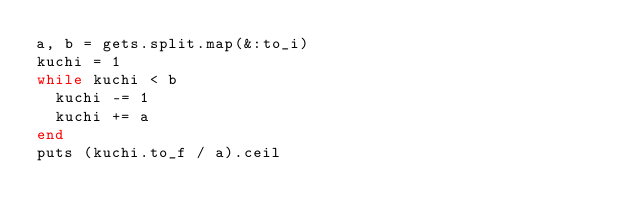<code> <loc_0><loc_0><loc_500><loc_500><_Ruby_>a, b = gets.split.map(&:to_i)
kuchi = 1
while kuchi < b
  kuchi -= 1
  kuchi += a
end
puts (kuchi.to_f / a).ceil</code> 